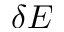Convert formula to latex. <formula><loc_0><loc_0><loc_500><loc_500>\delta E</formula> 